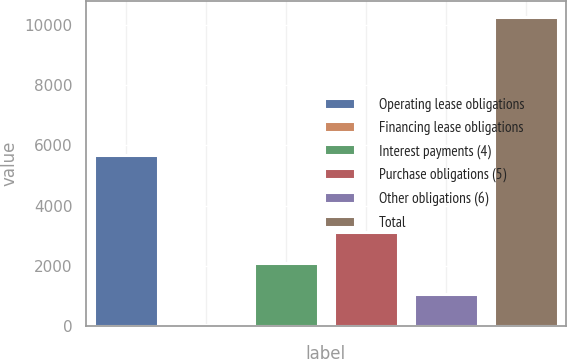Convert chart to OTSL. <chart><loc_0><loc_0><loc_500><loc_500><bar_chart><fcel>Operating lease obligations<fcel>Financing lease obligations<fcel>Interest payments (4)<fcel>Purchase obligations (5)<fcel>Other obligations (6)<fcel>Total<nl><fcel>5669.5<fcel>47.1<fcel>2091.2<fcel>3113.25<fcel>1069.15<fcel>10267.6<nl></chart> 